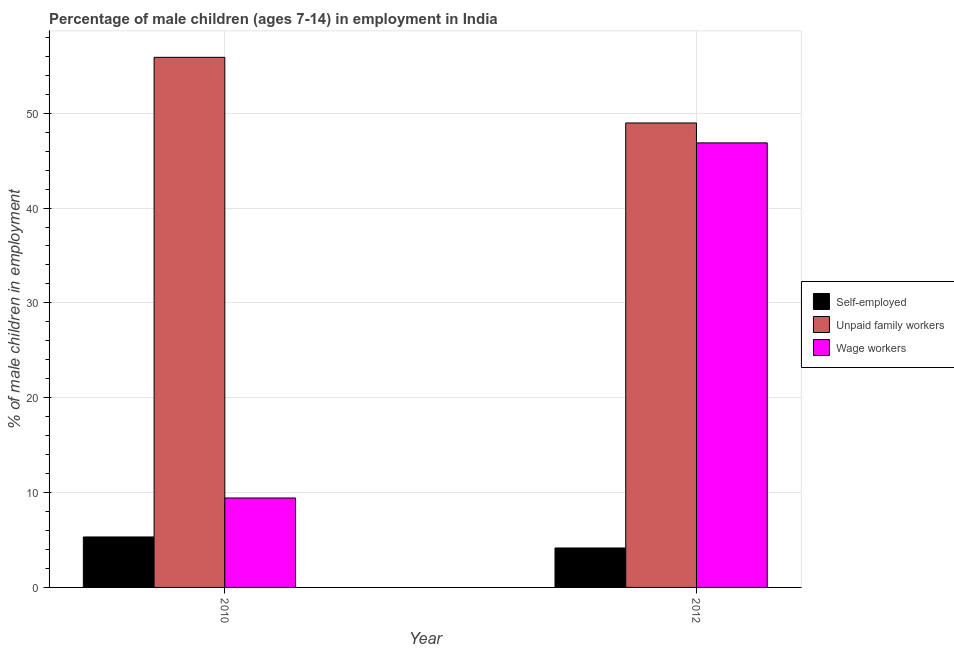How many different coloured bars are there?
Offer a very short reply. 3. How many groups of bars are there?
Your answer should be very brief. 2. Are the number of bars per tick equal to the number of legend labels?
Your answer should be compact. Yes. How many bars are there on the 2nd tick from the left?
Offer a terse response. 3. How many bars are there on the 1st tick from the right?
Your answer should be very brief. 3. What is the label of the 1st group of bars from the left?
Your answer should be very brief. 2010. In how many cases, is the number of bars for a given year not equal to the number of legend labels?
Your answer should be very brief. 0. What is the percentage of self employed children in 2010?
Offer a very short reply. 5.32. Across all years, what is the maximum percentage of children employed as wage workers?
Give a very brief answer. 46.87. Across all years, what is the minimum percentage of self employed children?
Ensure brevity in your answer.  4.16. In which year was the percentage of self employed children minimum?
Your response must be concise. 2012. What is the total percentage of children employed as wage workers in the graph?
Your answer should be compact. 56.3. What is the difference between the percentage of self employed children in 2010 and that in 2012?
Make the answer very short. 1.16. What is the difference between the percentage of children employed as wage workers in 2010 and the percentage of children employed as unpaid family workers in 2012?
Provide a short and direct response. -37.44. What is the average percentage of children employed as unpaid family workers per year?
Offer a terse response. 52.43. In the year 2010, what is the difference between the percentage of children employed as unpaid family workers and percentage of self employed children?
Your response must be concise. 0. In how many years, is the percentage of self employed children greater than 40 %?
Give a very brief answer. 0. What is the ratio of the percentage of children employed as unpaid family workers in 2010 to that in 2012?
Offer a terse response. 1.14. What does the 3rd bar from the left in 2012 represents?
Make the answer very short. Wage workers. What does the 2nd bar from the right in 2010 represents?
Make the answer very short. Unpaid family workers. Is it the case that in every year, the sum of the percentage of self employed children and percentage of children employed as unpaid family workers is greater than the percentage of children employed as wage workers?
Make the answer very short. Yes. How many years are there in the graph?
Your response must be concise. 2. What is the difference between two consecutive major ticks on the Y-axis?
Your response must be concise. 10. Does the graph contain any zero values?
Keep it short and to the point. No. What is the title of the graph?
Offer a very short reply. Percentage of male children (ages 7-14) in employment in India. Does "Negligence towards kids" appear as one of the legend labels in the graph?
Make the answer very short. No. What is the label or title of the Y-axis?
Provide a succinct answer. % of male children in employment. What is the % of male children in employment of Self-employed in 2010?
Make the answer very short. 5.32. What is the % of male children in employment in Unpaid family workers in 2010?
Offer a very short reply. 55.89. What is the % of male children in employment in Wage workers in 2010?
Your response must be concise. 9.43. What is the % of male children in employment of Self-employed in 2012?
Keep it short and to the point. 4.16. What is the % of male children in employment in Unpaid family workers in 2012?
Keep it short and to the point. 48.97. What is the % of male children in employment in Wage workers in 2012?
Provide a short and direct response. 46.87. Across all years, what is the maximum % of male children in employment in Self-employed?
Provide a succinct answer. 5.32. Across all years, what is the maximum % of male children in employment of Unpaid family workers?
Make the answer very short. 55.89. Across all years, what is the maximum % of male children in employment of Wage workers?
Make the answer very short. 46.87. Across all years, what is the minimum % of male children in employment of Self-employed?
Make the answer very short. 4.16. Across all years, what is the minimum % of male children in employment of Unpaid family workers?
Keep it short and to the point. 48.97. Across all years, what is the minimum % of male children in employment of Wage workers?
Provide a short and direct response. 9.43. What is the total % of male children in employment in Self-employed in the graph?
Give a very brief answer. 9.48. What is the total % of male children in employment of Unpaid family workers in the graph?
Offer a terse response. 104.86. What is the total % of male children in employment of Wage workers in the graph?
Your response must be concise. 56.3. What is the difference between the % of male children in employment of Self-employed in 2010 and that in 2012?
Give a very brief answer. 1.16. What is the difference between the % of male children in employment of Unpaid family workers in 2010 and that in 2012?
Your answer should be very brief. 6.92. What is the difference between the % of male children in employment in Wage workers in 2010 and that in 2012?
Provide a short and direct response. -37.44. What is the difference between the % of male children in employment of Self-employed in 2010 and the % of male children in employment of Unpaid family workers in 2012?
Ensure brevity in your answer.  -43.65. What is the difference between the % of male children in employment of Self-employed in 2010 and the % of male children in employment of Wage workers in 2012?
Provide a succinct answer. -41.55. What is the difference between the % of male children in employment of Unpaid family workers in 2010 and the % of male children in employment of Wage workers in 2012?
Provide a short and direct response. 9.02. What is the average % of male children in employment of Self-employed per year?
Your answer should be compact. 4.74. What is the average % of male children in employment in Unpaid family workers per year?
Your answer should be very brief. 52.43. What is the average % of male children in employment of Wage workers per year?
Keep it short and to the point. 28.15. In the year 2010, what is the difference between the % of male children in employment of Self-employed and % of male children in employment of Unpaid family workers?
Offer a very short reply. -50.57. In the year 2010, what is the difference between the % of male children in employment of Self-employed and % of male children in employment of Wage workers?
Keep it short and to the point. -4.11. In the year 2010, what is the difference between the % of male children in employment in Unpaid family workers and % of male children in employment in Wage workers?
Provide a short and direct response. 46.46. In the year 2012, what is the difference between the % of male children in employment of Self-employed and % of male children in employment of Unpaid family workers?
Make the answer very short. -44.81. In the year 2012, what is the difference between the % of male children in employment in Self-employed and % of male children in employment in Wage workers?
Provide a short and direct response. -42.71. What is the ratio of the % of male children in employment in Self-employed in 2010 to that in 2012?
Offer a very short reply. 1.28. What is the ratio of the % of male children in employment of Unpaid family workers in 2010 to that in 2012?
Provide a short and direct response. 1.14. What is the ratio of the % of male children in employment of Wage workers in 2010 to that in 2012?
Give a very brief answer. 0.2. What is the difference between the highest and the second highest % of male children in employment of Self-employed?
Your response must be concise. 1.16. What is the difference between the highest and the second highest % of male children in employment in Unpaid family workers?
Offer a terse response. 6.92. What is the difference between the highest and the second highest % of male children in employment of Wage workers?
Make the answer very short. 37.44. What is the difference between the highest and the lowest % of male children in employment of Self-employed?
Offer a terse response. 1.16. What is the difference between the highest and the lowest % of male children in employment of Unpaid family workers?
Make the answer very short. 6.92. What is the difference between the highest and the lowest % of male children in employment in Wage workers?
Your answer should be very brief. 37.44. 